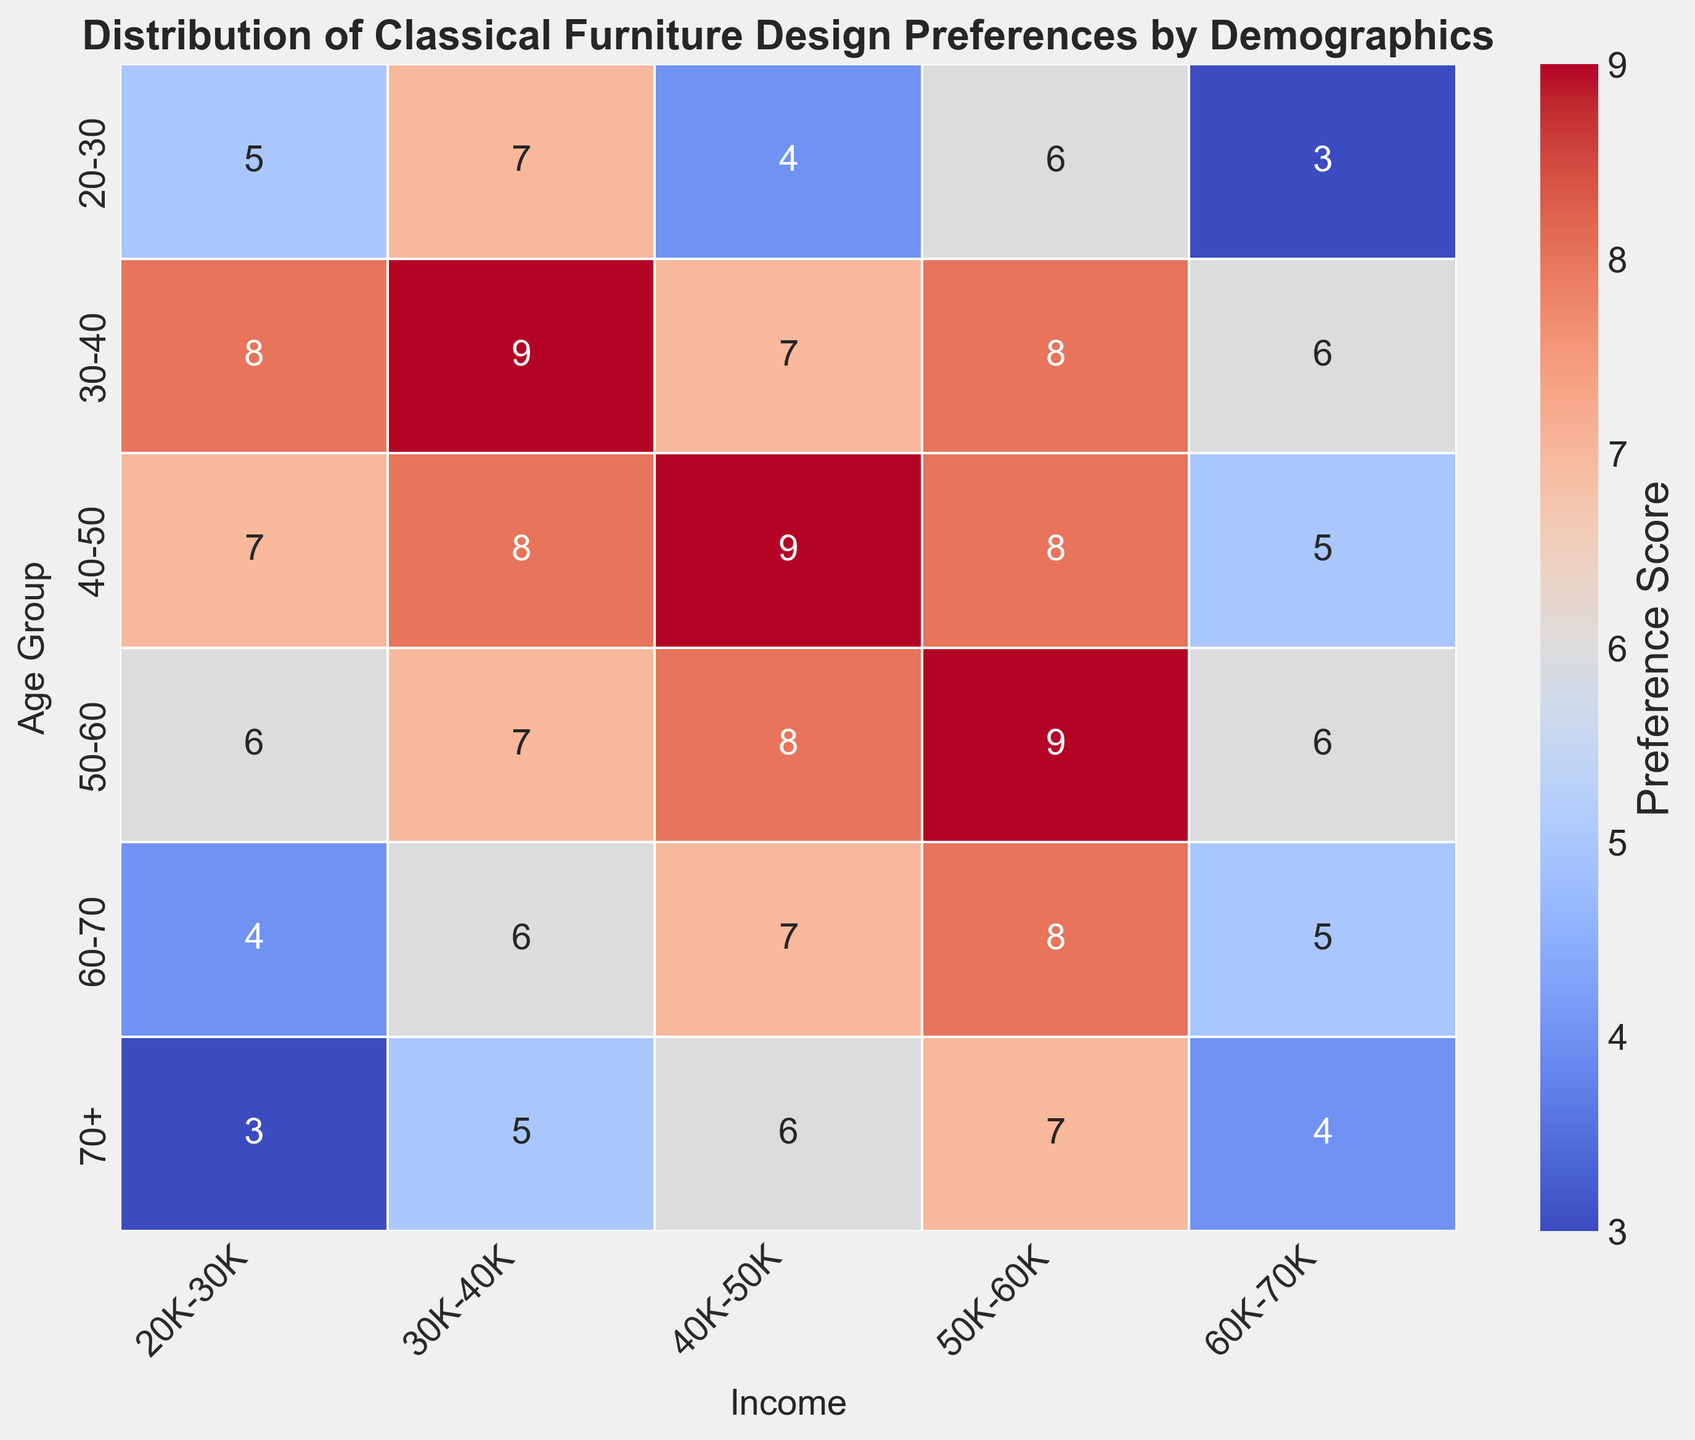What age group prefers classical furniture design the most? By looking at the heatmap, identify the age group with the highest preference score. The darkest spot (highest score) is in the '30-40' age group at an income range of '30K-40K' with a score of 9. Thus, the '30-40' age group appears to have the highest preference for classical furniture design.
Answer: 30-40 Which age group consistently shows moderate to high preference scores (scores 5 and higher) across all income categories? Across the heatmap, scan for age groups that have scores of 5 and higher in all income categories. The '40-50' and '50-60' age groups consistently score 5 and above across all income levels, indicating preference in every income category.
Answer: 40-50 and 50-60 In the '50-60' age group, what is the difference in preference scores between the highest and lowest income categories? Focus on the '50-60' age group row and identify the highest and lowest preference scores. The highest score is 9 (50K-60K), and the lowest score is 6 (20K-30K & 60K-70K). Calculate the difference, which is 9 - 6 = 3.
Answer: 3 Which income category shows the highest variation in preference scores across different age groups? Observe the columns (income categories) to identify which one has the most variability in scores. The '40K-50K' category ranges from 4 (20-30 age group) to 9 (40-50 age group), showing the largest spread and thus the highest variation.
Answer: 40K-50K How do preference scores for the '20-30' age group compare to the '60-70' age group across different income levels? Compare the rows for '20-30' and '60-70' in the heatmap. Generally, the '60-70' age group has slightly higher scores: '20-30' scores range from 3 to 7, while '60-70' scores range from 4 to 8, indicating a general increase in preference as we move from younger to older age groups.
Answer: Higher in '60-70' age group Looking at the visual distribution, which age group has the least preference for classical furniture in the highest income category (60K-70K)? Locate the '60K-70K' income category column and identify the row (age group) with the lightest color. The '20-30' age group has the lightest shade with a score of 3, indicating the least preference in this income bracket.
Answer: 20-30 For the '30-40' age group, what is the average preference score across all income categories? Identify the scores for '30-40' age group: 8, 9, 7, 8, 6. Sum these up: (8+9+7+8+6)=38, then divide by the number of categories (5), resulting in an average score of 38/5=7.6.
Answer: 7.6 In terms of visual intensity, is the preference for classical furniture higher in the '40-50' age group compared to the '70+' age group? Compare the color intensity between the '40-50' and '70+' rows. The '40-50' row generally has darker shades, indicating higher preference scores, compared to the '70+' row, which has lighter colors.
Answer: Yes 